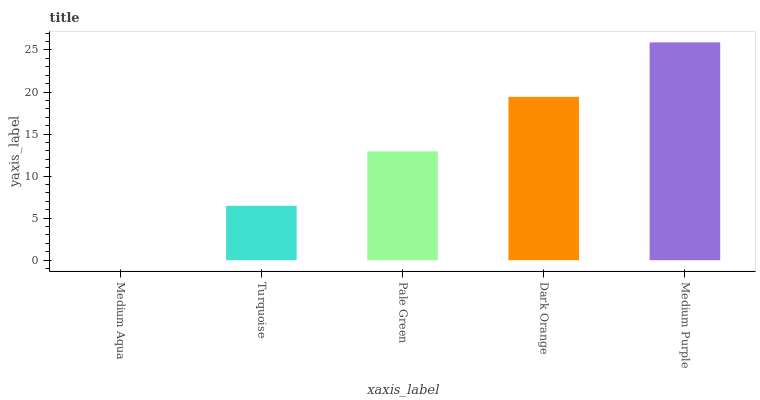Is Medium Aqua the minimum?
Answer yes or no. Yes. Is Medium Purple the maximum?
Answer yes or no. Yes. Is Turquoise the minimum?
Answer yes or no. No. Is Turquoise the maximum?
Answer yes or no. No. Is Turquoise greater than Medium Aqua?
Answer yes or no. Yes. Is Medium Aqua less than Turquoise?
Answer yes or no. Yes. Is Medium Aqua greater than Turquoise?
Answer yes or no. No. Is Turquoise less than Medium Aqua?
Answer yes or no. No. Is Pale Green the high median?
Answer yes or no. Yes. Is Pale Green the low median?
Answer yes or no. Yes. Is Medium Purple the high median?
Answer yes or no. No. Is Medium Aqua the low median?
Answer yes or no. No. 